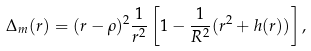Convert formula to latex. <formula><loc_0><loc_0><loc_500><loc_500>\Delta _ { m } ( r ) = ( r - \rho ) ^ { 2 } \frac { 1 } { r ^ { 2 } } \left [ 1 - \frac { 1 } { R ^ { 2 } } ( r ^ { 2 } + h ( r ) ) \right ] ,</formula> 